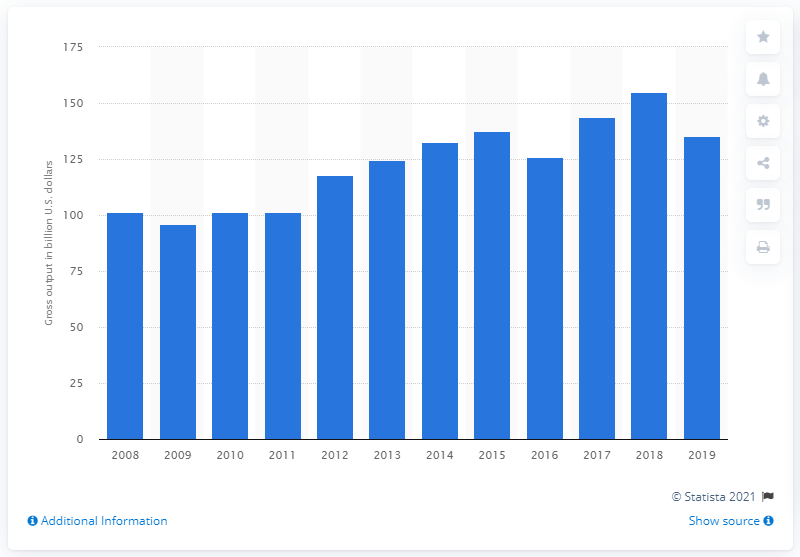Outline some significant characteristics in this image. In 2019, the gross output of the aircraft manufacturing industry was 135.3 billion U.S. dollars. 